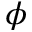Convert formula to latex. <formula><loc_0><loc_0><loc_500><loc_500>\phi</formula> 